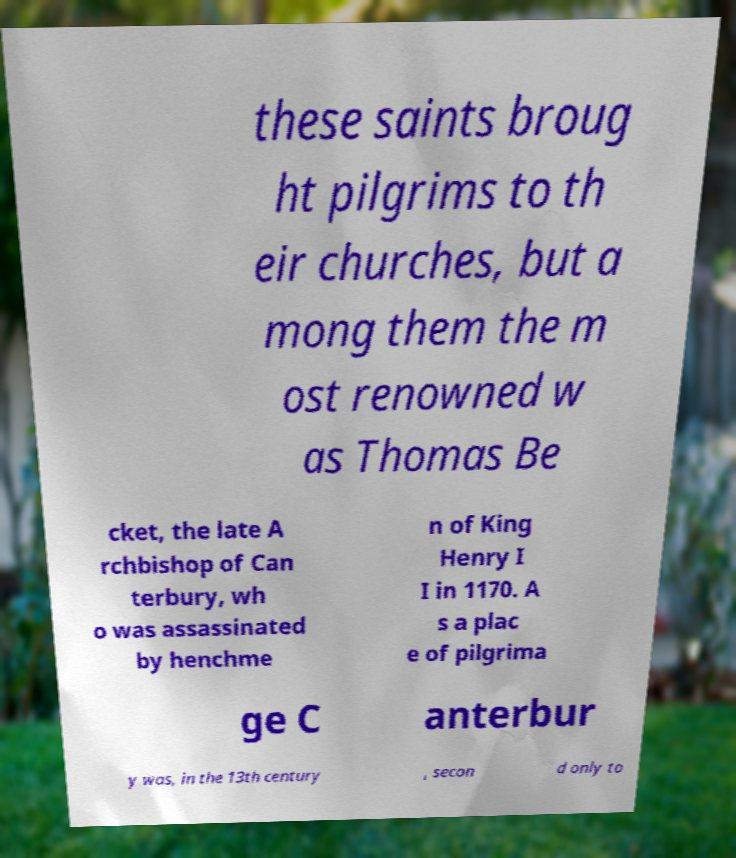Please read and relay the text visible in this image. What does it say? these saints broug ht pilgrims to th eir churches, but a mong them the m ost renowned w as Thomas Be cket, the late A rchbishop of Can terbury, wh o was assassinated by henchme n of King Henry I I in 1170. A s a plac e of pilgrima ge C anterbur y was, in the 13th century , secon d only to 